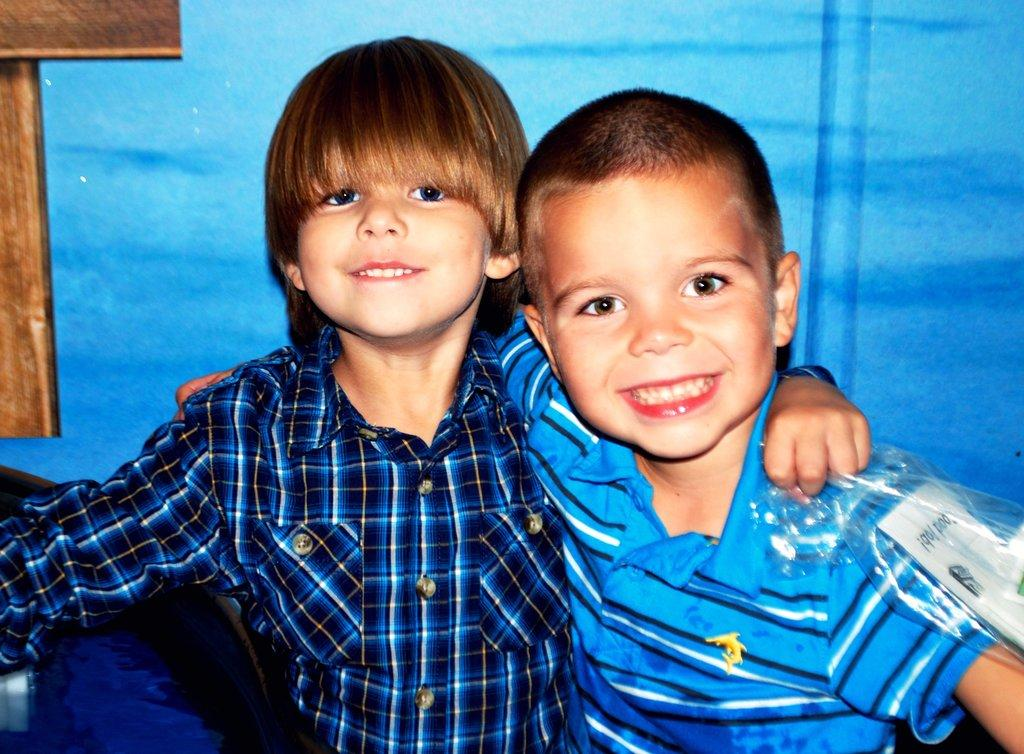How many people are in the image? There are two boys in the image. What are the boys doing in the image? The boys are smiling and posing for a photo. What color is the background in the image? The background in the image is blue. What can be seen on the left side of the image? There is a wooden object on the left side of the image. What type of crown is the boy wearing in the image? There is no crown visible in the image; the boys are not wearing any headwear. How can you tell that the boys are being quiet in the image? The boys are not depicted as being quiet or not in the image; they are smiling and posing for a photo. 